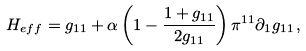<formula> <loc_0><loc_0><loc_500><loc_500>H _ { e f f } = g _ { 1 1 } + \alpha \left ( 1 - \frac { 1 + g _ { 1 1 } } { 2 g _ { 1 1 } } \right ) \pi ^ { 1 1 } \partial _ { 1 } g _ { 1 1 } \, ,</formula> 